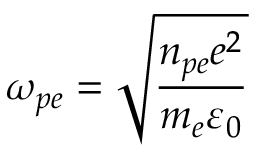<formula> <loc_0><loc_0><loc_500><loc_500>\omega _ { p e } = \sqrt { \frac { n _ { p e } e ^ { 2 } } { m _ { e } \varepsilon _ { 0 } } }</formula> 